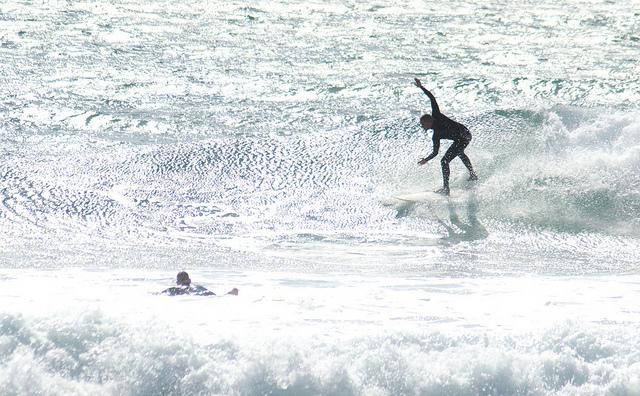How many surfers are in this photo?
Answer briefly. 2. How many surfers are there?
Concise answer only. 2. What color shirt is the surfer wearing?
Answer briefly. Black. What are the people doing?
Keep it brief. Surfing. Are the waters calm?
Concise answer only. No. 